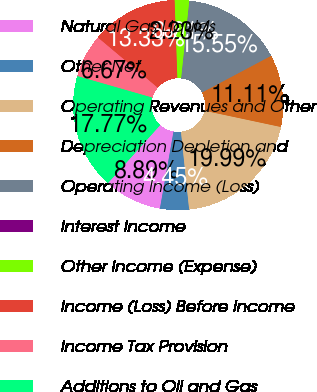Convert chart to OTSL. <chart><loc_0><loc_0><loc_500><loc_500><pie_chart><fcel>Natural Gas Liquids<fcel>Other Net<fcel>Operating Revenues and Other<fcel>Depreciation Depletion and<fcel>Operating Income (Loss)<fcel>Interest Income<fcel>Other Income (Expense)<fcel>Income (Loss) Before Income<fcel>Income Tax Provision<fcel>Additions to Oil and Gas<nl><fcel>8.89%<fcel>4.45%<fcel>19.99%<fcel>11.11%<fcel>15.55%<fcel>0.01%<fcel>2.23%<fcel>13.33%<fcel>6.67%<fcel>17.77%<nl></chart> 